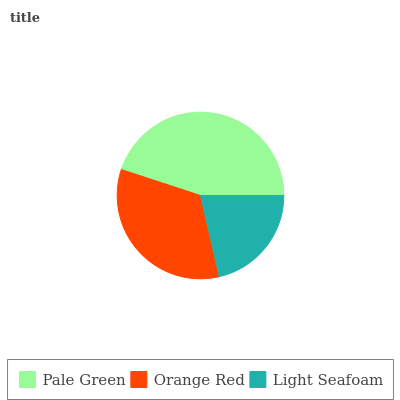Is Light Seafoam the minimum?
Answer yes or no. Yes. Is Pale Green the maximum?
Answer yes or no. Yes. Is Orange Red the minimum?
Answer yes or no. No. Is Orange Red the maximum?
Answer yes or no. No. Is Pale Green greater than Orange Red?
Answer yes or no. Yes. Is Orange Red less than Pale Green?
Answer yes or no. Yes. Is Orange Red greater than Pale Green?
Answer yes or no. No. Is Pale Green less than Orange Red?
Answer yes or no. No. Is Orange Red the high median?
Answer yes or no. Yes. Is Orange Red the low median?
Answer yes or no. Yes. Is Pale Green the high median?
Answer yes or no. No. Is Pale Green the low median?
Answer yes or no. No. 